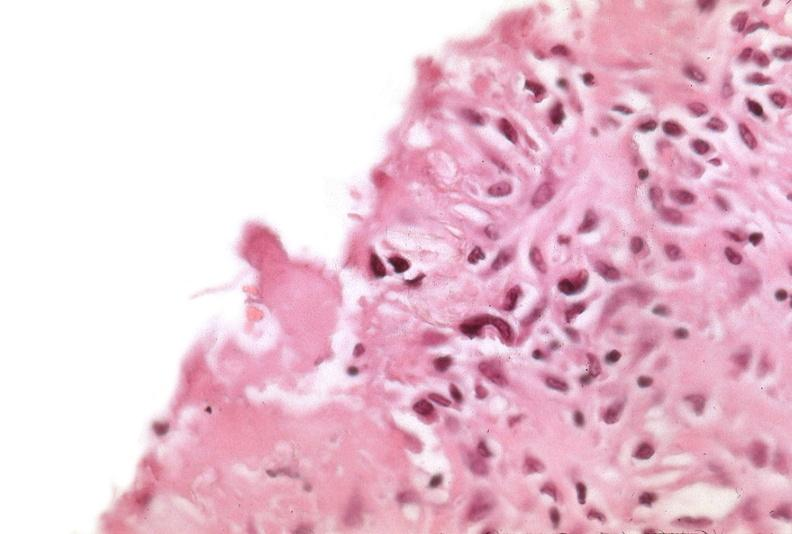what was talc used, alpha-1 antitrypsin deficiency?
Answer the question using a single word or phrase. Used to sclerose emphysematous lung 